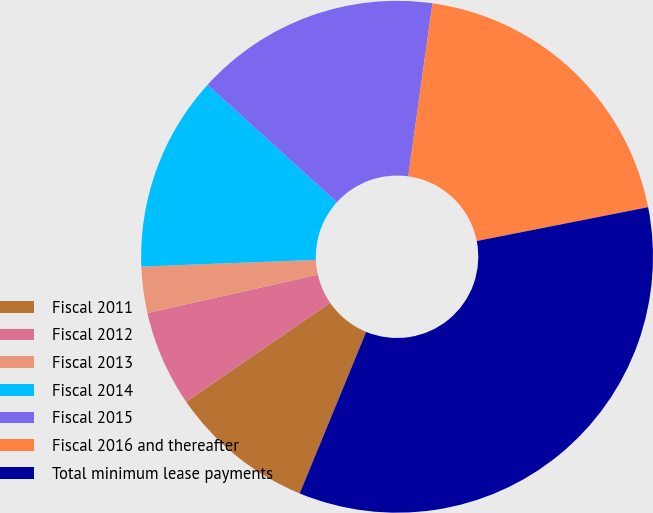Convert chart to OTSL. <chart><loc_0><loc_0><loc_500><loc_500><pie_chart><fcel>Fiscal 2011<fcel>Fiscal 2012<fcel>Fiscal 2013<fcel>Fiscal 2014<fcel>Fiscal 2015<fcel>Fiscal 2016 and thereafter<fcel>Total minimum lease payments<nl><fcel>9.2%<fcel>6.06%<fcel>2.92%<fcel>12.34%<fcel>15.48%<fcel>19.69%<fcel>34.32%<nl></chart> 